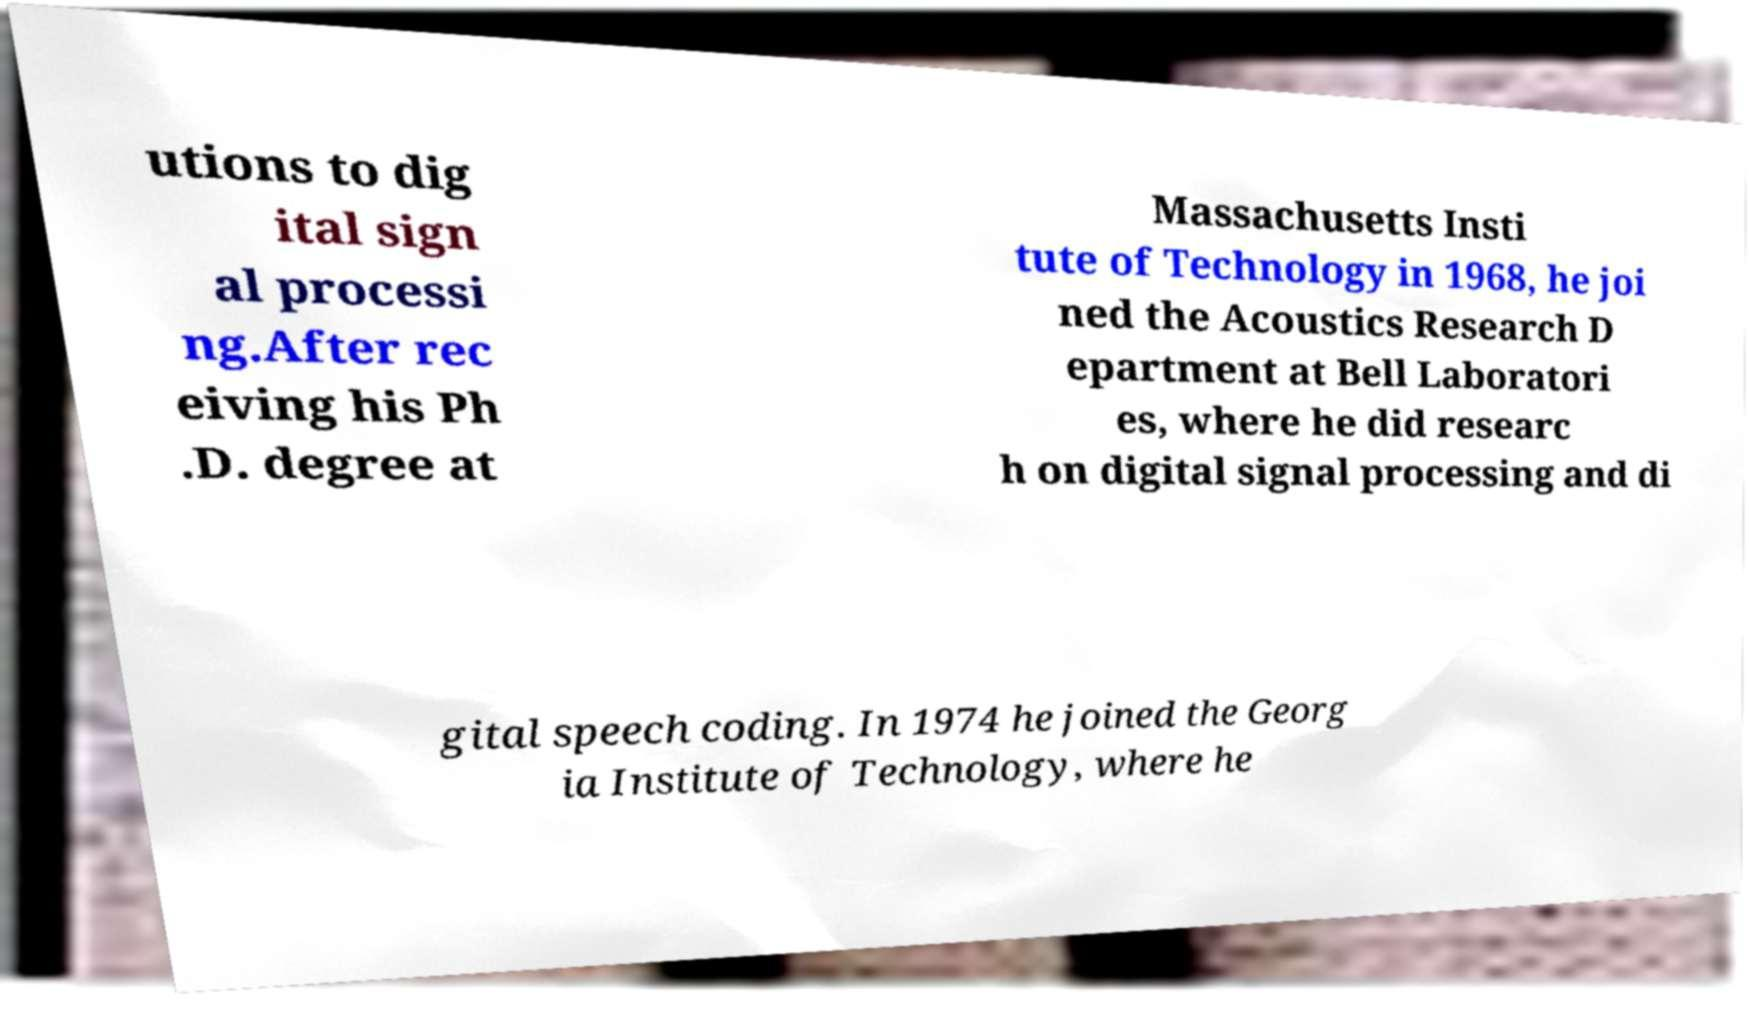Could you extract and type out the text from this image? utions to dig ital sign al processi ng.After rec eiving his Ph .D. degree at Massachusetts Insti tute of Technology in 1968, he joi ned the Acoustics Research D epartment at Bell Laboratori es, where he did researc h on digital signal processing and di gital speech coding. In 1974 he joined the Georg ia Institute of Technology, where he 